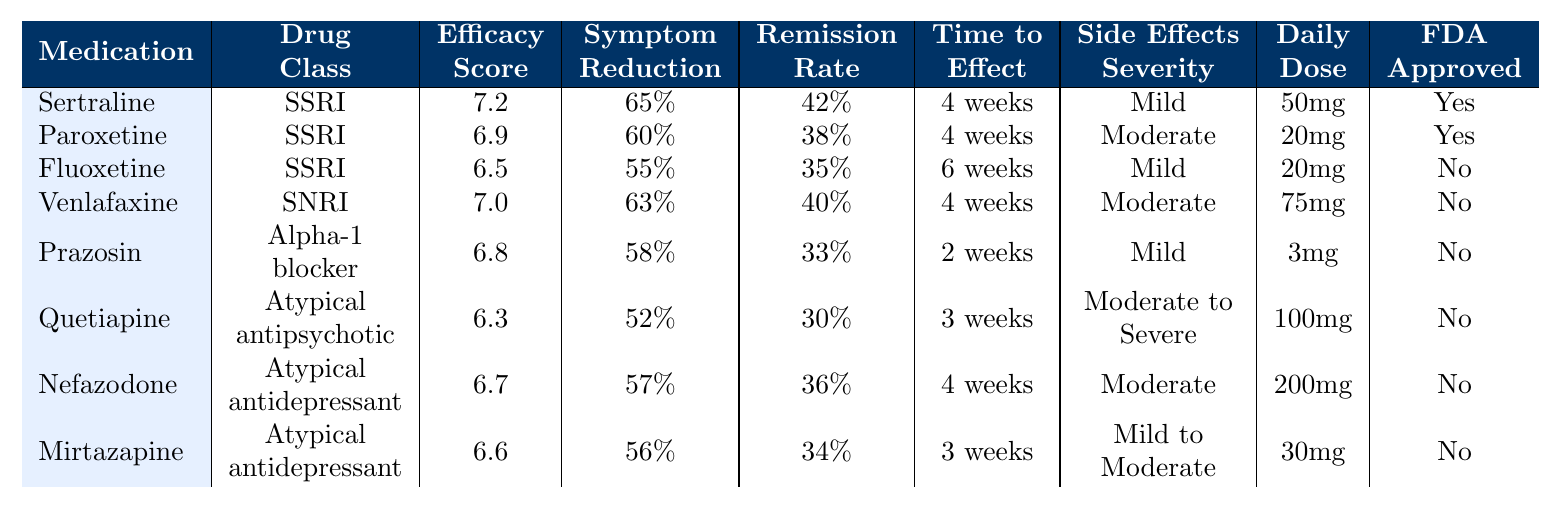What is the average efficacy score of the medications listed? To find the average efficacy score, add the scores: 7.2 + 6.9 + 6.5 + 7.0 + 6.8 + 6.3 + 6.7 + 6.6 = 54.0. Then divide by the number of medications (8): 54.0 / 8 = 6.75.
Answer: 6.75 Which medication has the highest symptom reduction percentage? The symptom reduction percentages are: Sertraline (65%), Paroxetine (60%), Fluoxetine (55%), Venlafaxine (63%), Prazosin (58%), Quetiapine (52%), Nefazodone (57%), Mirtazapine (56%). Sertraline has the highest percentage at 65%.
Answer: Sertraline Is Venlafaxine FDA approved for PTSD treatment? The table indicates FDA approval statuses. Venlafaxine is marked as "No," meaning it is not FDA approved for PTSD.
Answer: No What is the time to effect for Prazosin? The table shows that Prazosin has a time to effect of 2 weeks.
Answer: 2 weeks Which medication has the lowest remission rate, and what is that rate? The remission rates are as follows: Sertraline (42%), Paroxetine (38%), Fluoxetine (35%), Venlafaxine (40%), Prazosin (33%), Quetiapine (30%), Nefazodone (36%), Mirtazapine (34%). Quetiapine has the lowest rate at 30%.
Answer: Quetiapine, 30% What is the difference in average efficacy scores between the medications that are FDA approved and those that are not? The average efficacy score for FDA approved medications (Sertraline and Paroxetine) is (7.2 + 6.9) / 2 = 7.05. For non-FDA approved medications (Fluoxetine, Venlafaxine, Prazosin, Quetiapine, Nefazodone, Mirtazapine), it is (6.5 + 7.0 + 6.8 + 6.3 + 6.7 + 6.6) / 6 = 6.6. The difference is 7.05 - 6.6 = 0.45.
Answer: 0.45 How many medications have mild side effects severity? The medications with mild side effects are: Sertraline, Fluoxetine, Prazosin, and Mirtazapine, totaling 4 medications.
Answer: 4 medications What percentage of medications listed are FDA approved for PTSD? There are 2 FDA approved medications (Sertraline and Paroxetine) out of 8 total medications. The percentage is (2 / 8) * 100 = 25%.
Answer: 25% Is the recommended daily dose for Quetiapine greater than 75 mg? The table shows the recommended daily dose for Quetiapine is 100 mg, which is indeed greater than 75 mg.
Answer: Yes Which drug class does Paroxetine belong to? According to the table, Paroxetine is listed under the SSRI class.
Answer: SSRI What is the average time to effect for all medications combined? The times to effect are: 4 weeks (Sertraline), 4 weeks (Paroxetine), 6 weeks (Fluoxetine), 4 weeks (Venlafaxine), 2 weeks (Prazosin), 3 weeks (Quetiapine), 4 weeks (Nefazodone), and 3 weeks (Mirtazapine). In weeks, this translates to 4 + 4 + 6 + 4 + 2 + 3 + 4 + 3 = 30 weeks. We have 8 medications, so the average is 30 / 8 = 3.75 weeks.
Answer: 3.75 weeks 